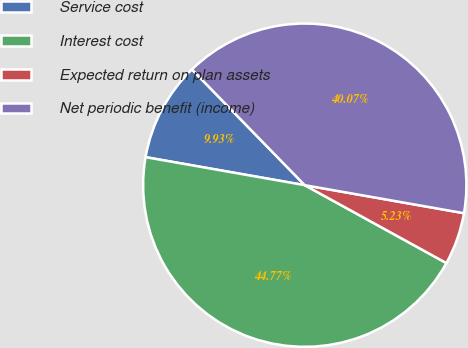Convert chart. <chart><loc_0><loc_0><loc_500><loc_500><pie_chart><fcel>Service cost<fcel>Interest cost<fcel>Expected return on plan assets<fcel>Net periodic benefit (income)<nl><fcel>9.93%<fcel>44.77%<fcel>5.23%<fcel>40.07%<nl></chart> 